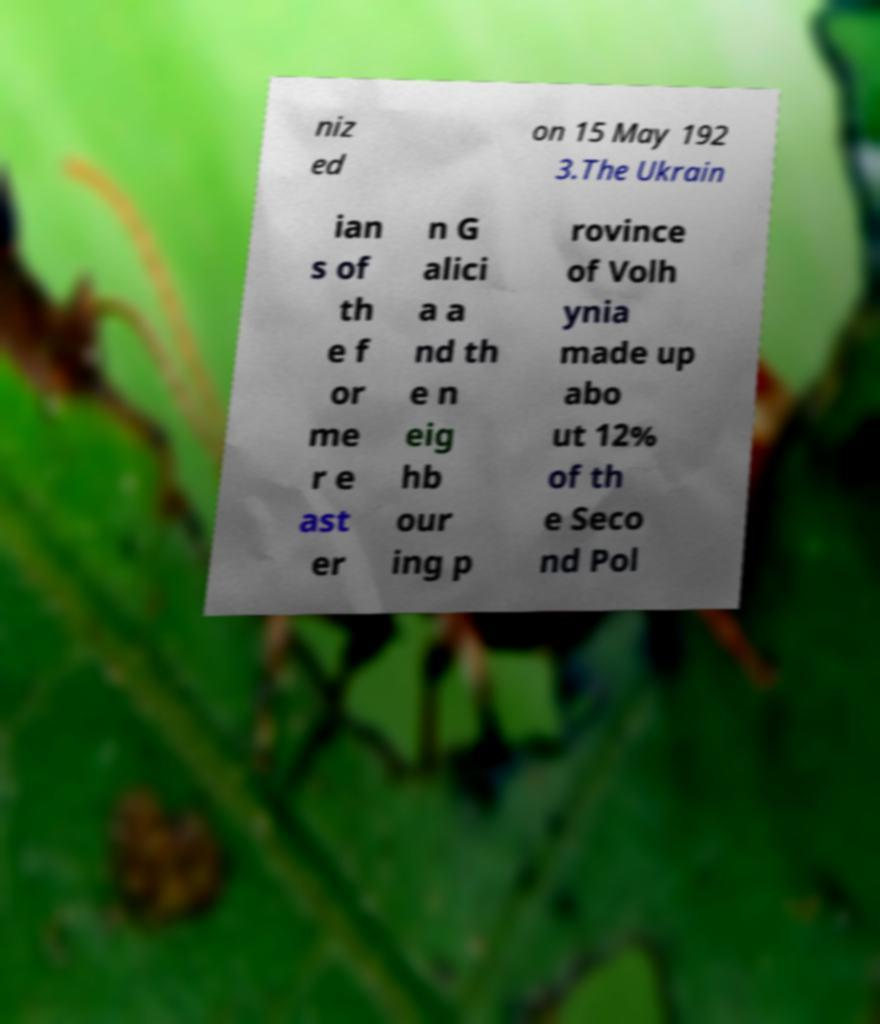What messages or text are displayed in this image? I need them in a readable, typed format. niz ed on 15 May 192 3.The Ukrain ian s of th e f or me r e ast er n G alici a a nd th e n eig hb our ing p rovince of Volh ynia made up abo ut 12% of th e Seco nd Pol 